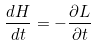<formula> <loc_0><loc_0><loc_500><loc_500>\frac { d H } { d t } = - \frac { \partial L } { \partial t }</formula> 